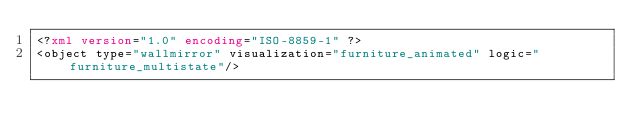Convert code to text. <code><loc_0><loc_0><loc_500><loc_500><_XML_><?xml version="1.0" encoding="ISO-8859-1" ?>
<object type="wallmirror" visualization="furniture_animated" logic="furniture_multistate"/>
</code> 